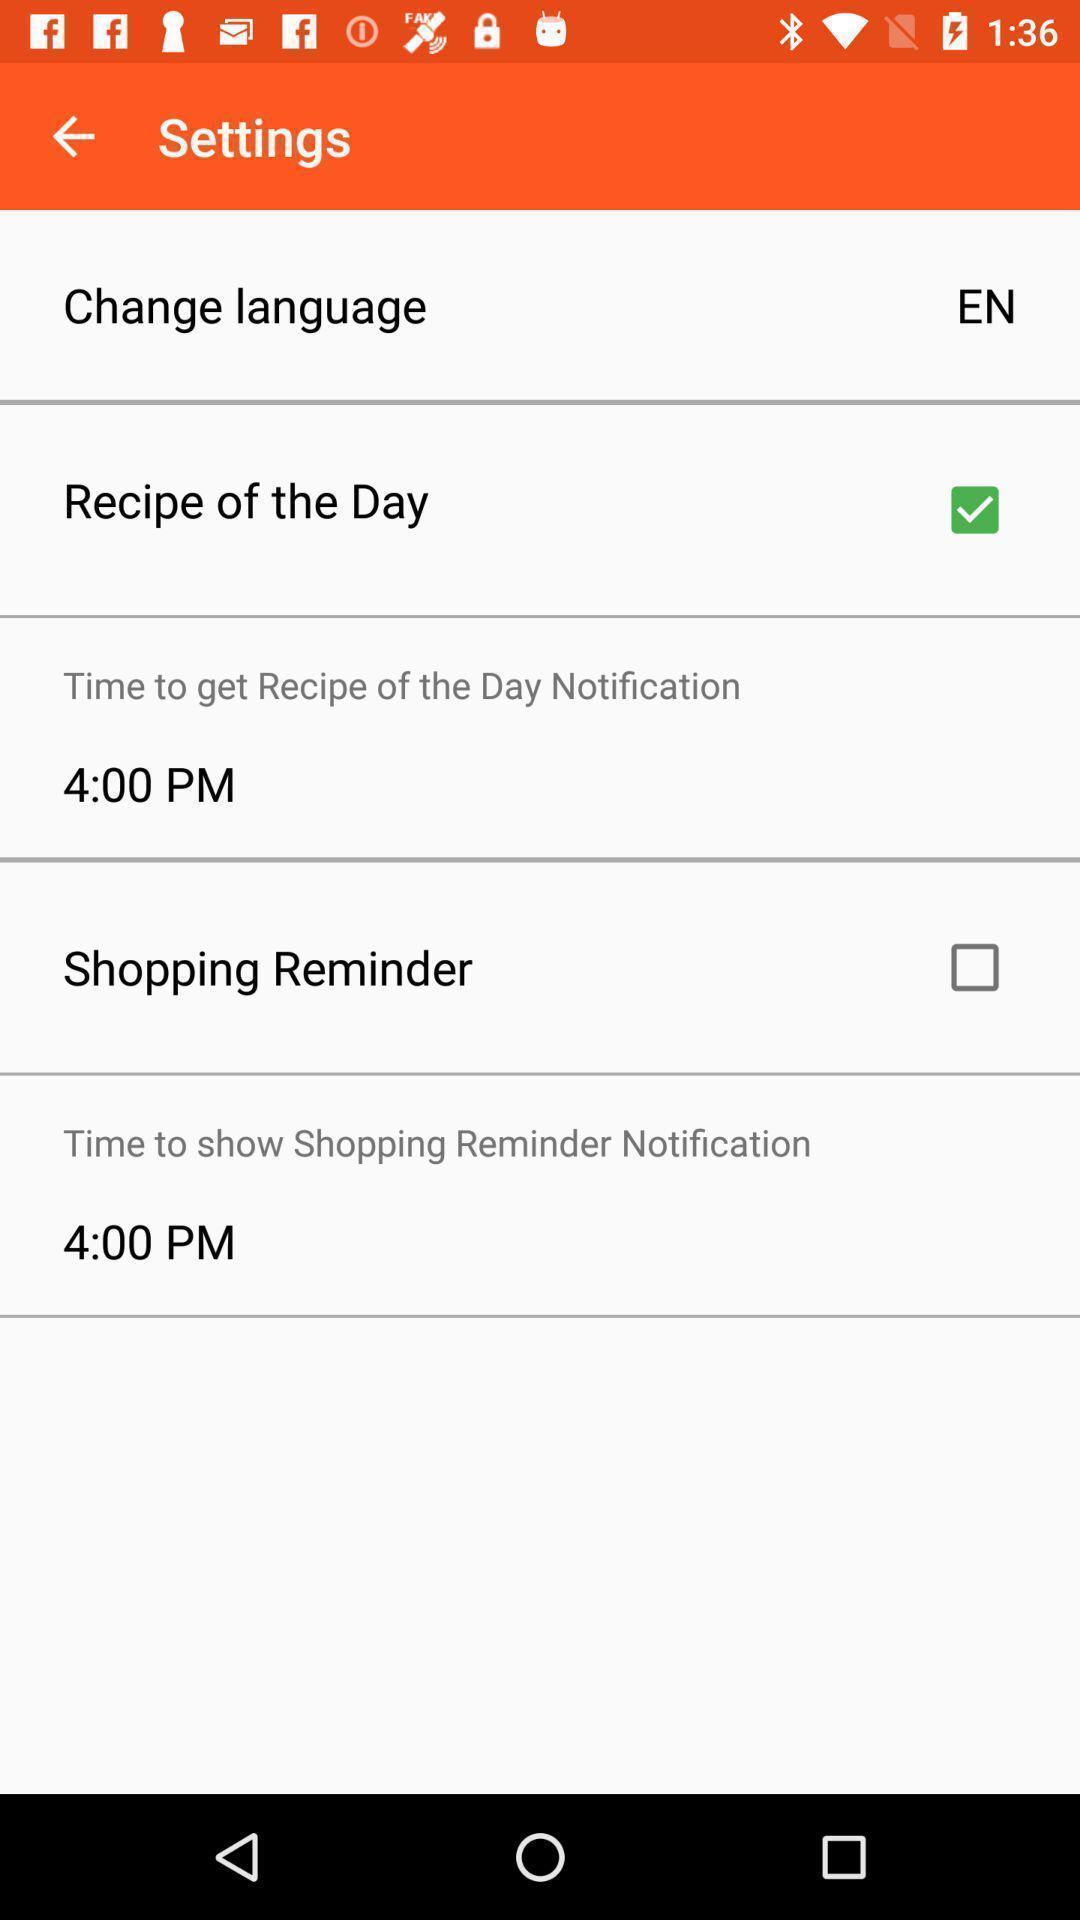What is the overall content of this screenshot? Shopping settings of a settings. 